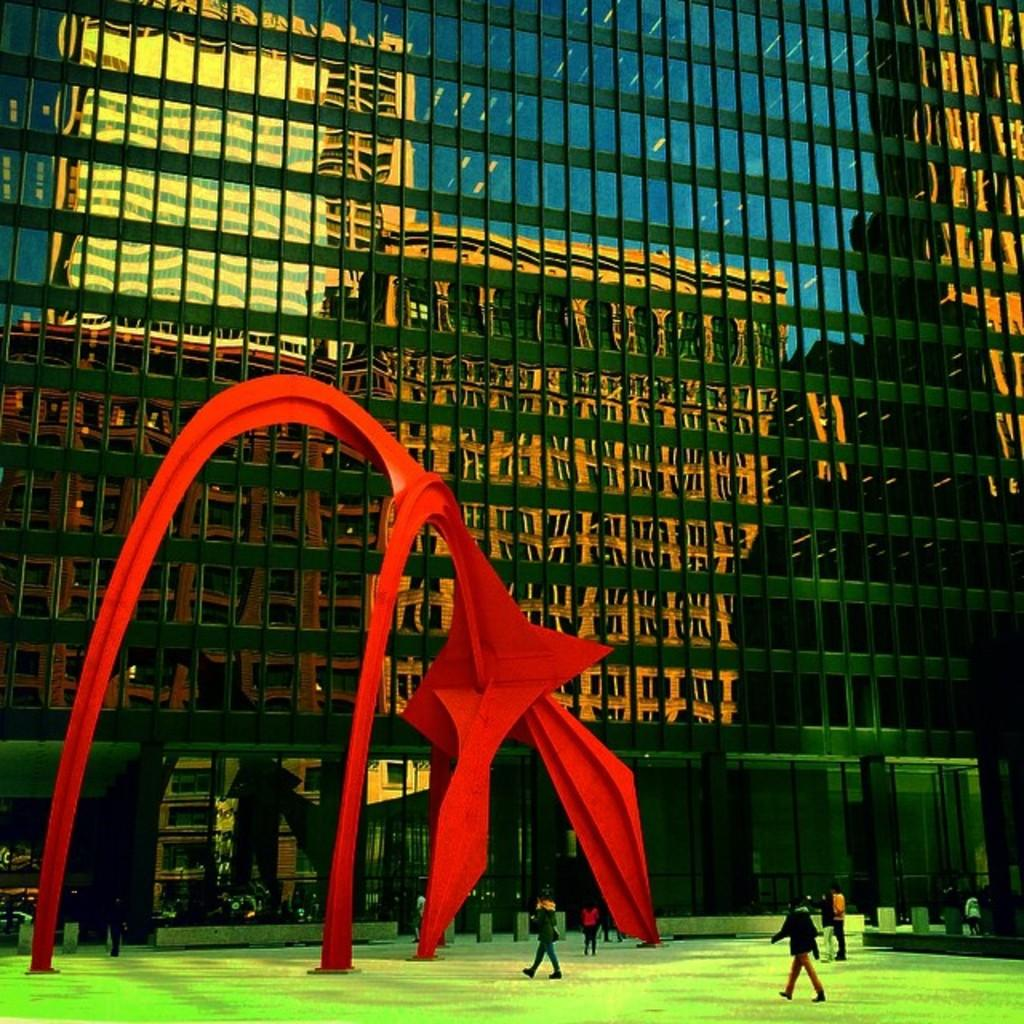What is happening with the group of people in the image? Some people are standing, while others are walking. Can you describe the red object in the image? There is an object in red color in the image, but its specific nature is not mentioned in the facts. What can be seen in the background of the image? There is a glass building in the background of the image. What type of wine is being served at the event in the image? There is no mention of an event or wine in the image or the provided facts. 